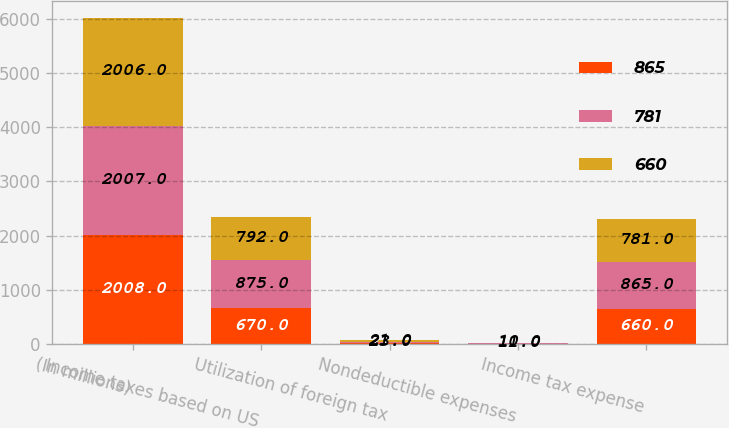Convert chart to OTSL. <chart><loc_0><loc_0><loc_500><loc_500><stacked_bar_chart><ecel><fcel>(In millions)<fcel>Income taxes based on US<fcel>Utilization of foreign tax<fcel>Nondeductible expenses<fcel>Income tax expense<nl><fcel>865<fcel>2008<fcel>670<fcel>27<fcel>11<fcel>660<nl><fcel>781<fcel>2007<fcel>875<fcel>23<fcel>11<fcel>865<nl><fcel>660<fcel>2006<fcel>792<fcel>21<fcel>10<fcel>781<nl></chart> 